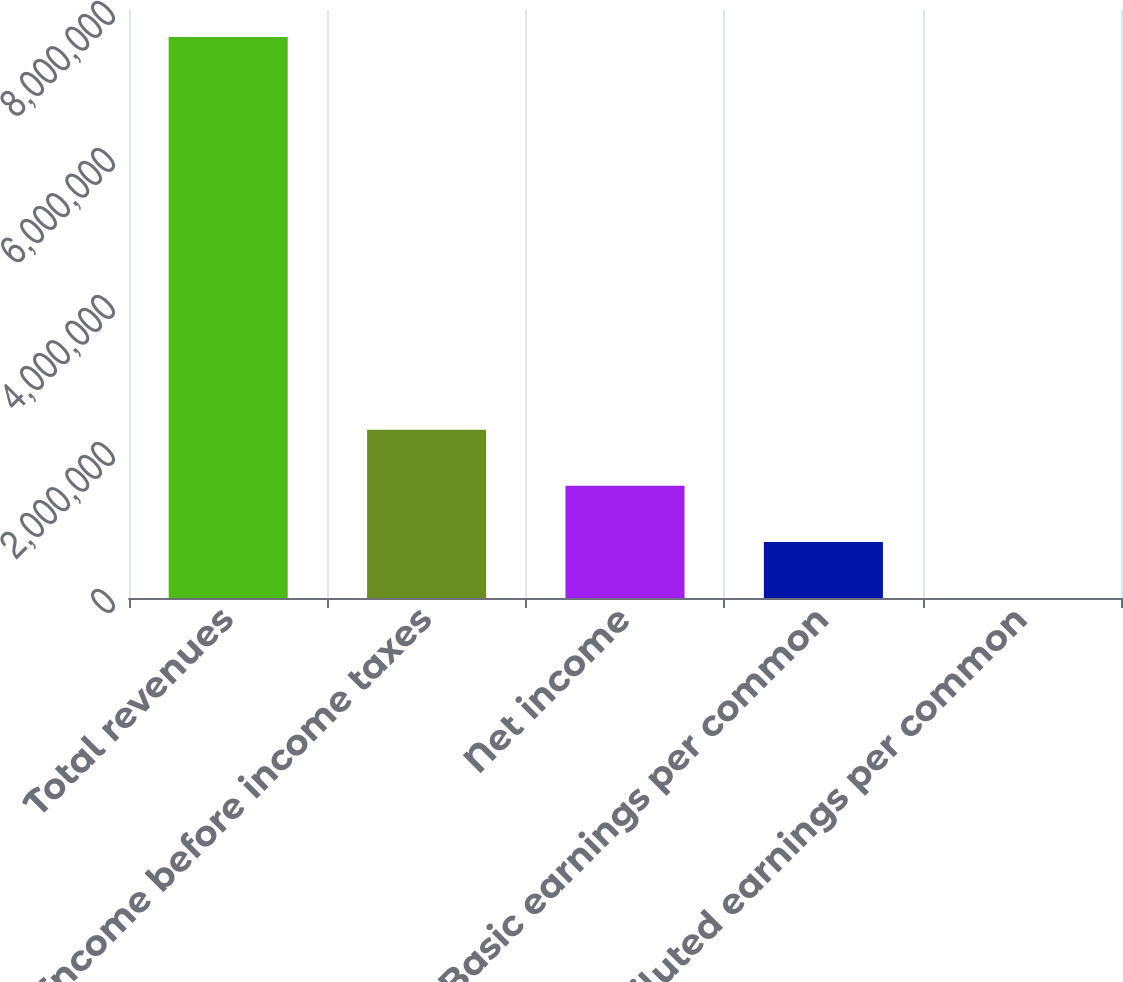Convert chart. <chart><loc_0><loc_0><loc_500><loc_500><bar_chart><fcel>Total revenues<fcel>Income before income taxes<fcel>Net income<fcel>Basic earnings per common<fcel>Diluted earnings per common<nl><fcel>7.63304e+06<fcel>2.28991e+06<fcel>1.52661e+06<fcel>763306<fcel>1.48<nl></chart> 